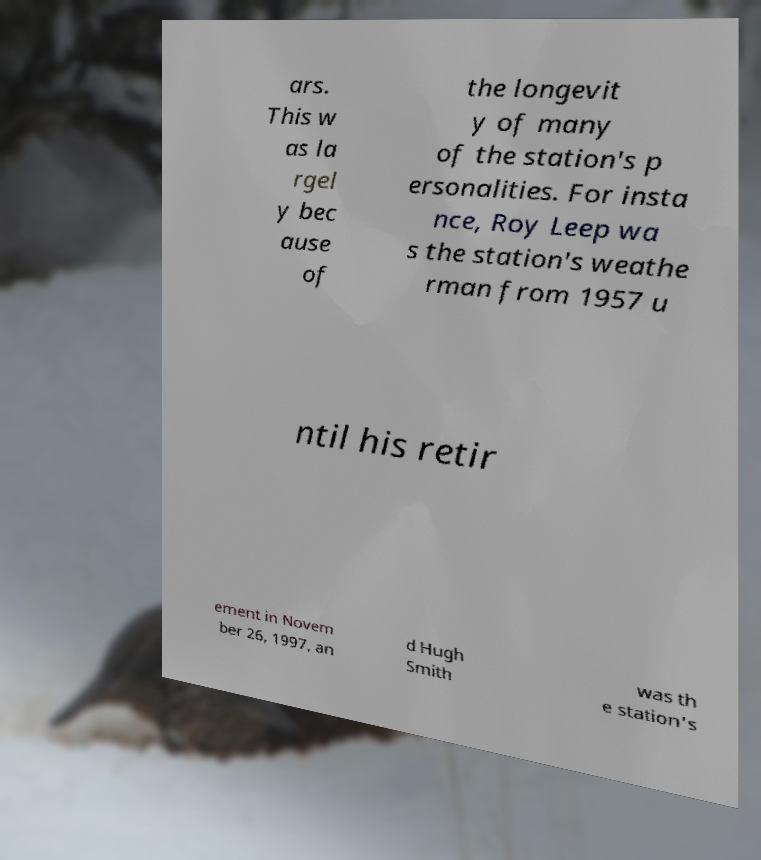What messages or text are displayed in this image? I need them in a readable, typed format. ars. This w as la rgel y bec ause of the longevit y of many of the station's p ersonalities. For insta nce, Roy Leep wa s the station's weathe rman from 1957 u ntil his retir ement in Novem ber 26, 1997, an d Hugh Smith was th e station's 